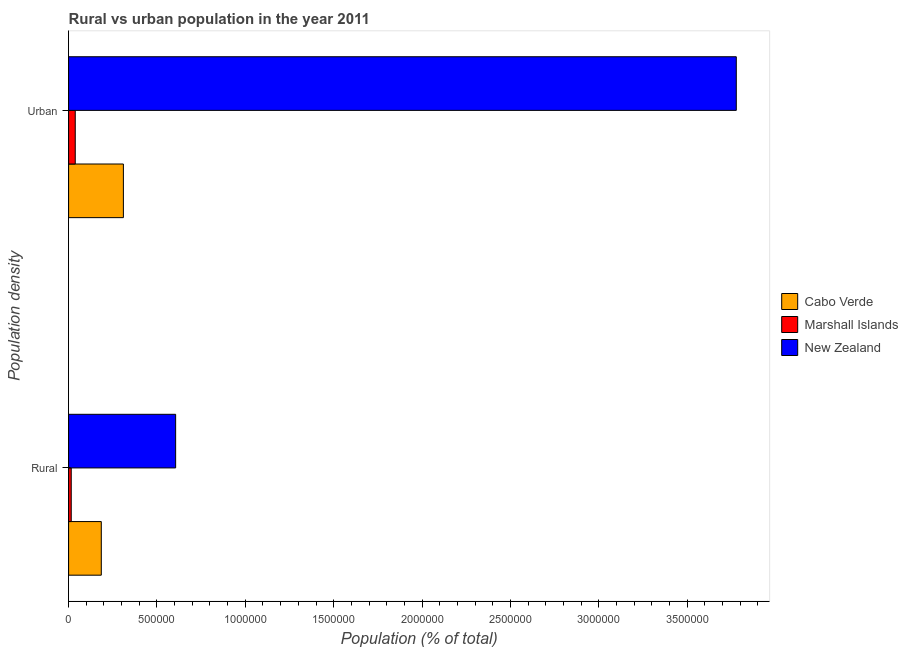How many groups of bars are there?
Offer a terse response. 2. Are the number of bars on each tick of the Y-axis equal?
Give a very brief answer. Yes. How many bars are there on the 2nd tick from the top?
Your answer should be very brief. 3. How many bars are there on the 1st tick from the bottom?
Ensure brevity in your answer.  3. What is the label of the 1st group of bars from the top?
Offer a terse response. Urban. What is the rural population density in Cabo Verde?
Your answer should be very brief. 1.85e+05. Across all countries, what is the maximum urban population density?
Provide a short and direct response. 3.78e+06. Across all countries, what is the minimum rural population density?
Your answer should be compact. 1.49e+04. In which country was the urban population density maximum?
Give a very brief answer. New Zealand. In which country was the rural population density minimum?
Provide a succinct answer. Marshall Islands. What is the total rural population density in the graph?
Offer a terse response. 8.06e+05. What is the difference between the urban population density in Cabo Verde and that in New Zealand?
Give a very brief answer. -3.47e+06. What is the difference between the urban population density in Marshall Islands and the rural population density in New Zealand?
Offer a very short reply. -5.68e+05. What is the average rural population density per country?
Offer a terse response. 2.69e+05. What is the difference between the urban population density and rural population density in New Zealand?
Provide a short and direct response. 3.17e+06. What is the ratio of the rural population density in New Zealand to that in Marshall Islands?
Keep it short and to the point. 40.62. In how many countries, is the rural population density greater than the average rural population density taken over all countries?
Make the answer very short. 1. What does the 1st bar from the top in Rural represents?
Keep it short and to the point. New Zealand. What does the 1st bar from the bottom in Urban represents?
Your response must be concise. Cabo Verde. How many countries are there in the graph?
Offer a terse response. 3. Are the values on the major ticks of X-axis written in scientific E-notation?
Your answer should be very brief. No. Does the graph contain any zero values?
Your response must be concise. No. Where does the legend appear in the graph?
Your answer should be compact. Center right. How many legend labels are there?
Ensure brevity in your answer.  3. How are the legend labels stacked?
Your response must be concise. Vertical. What is the title of the graph?
Keep it short and to the point. Rural vs urban population in the year 2011. What is the label or title of the X-axis?
Ensure brevity in your answer.  Population (% of total). What is the label or title of the Y-axis?
Offer a very short reply. Population density. What is the Population (% of total) in Cabo Verde in Rural?
Offer a terse response. 1.85e+05. What is the Population (% of total) in Marshall Islands in Rural?
Offer a terse response. 1.49e+04. What is the Population (% of total) of New Zealand in Rural?
Provide a short and direct response. 6.06e+05. What is the Population (% of total) of Cabo Verde in Urban?
Your response must be concise. 3.10e+05. What is the Population (% of total) of Marshall Islands in Urban?
Provide a succinct answer. 3.76e+04. What is the Population (% of total) in New Zealand in Urban?
Give a very brief answer. 3.78e+06. Across all Population density, what is the maximum Population (% of total) in Cabo Verde?
Offer a very short reply. 3.10e+05. Across all Population density, what is the maximum Population (% of total) in Marshall Islands?
Offer a very short reply. 3.76e+04. Across all Population density, what is the maximum Population (% of total) of New Zealand?
Provide a succinct answer. 3.78e+06. Across all Population density, what is the minimum Population (% of total) in Cabo Verde?
Ensure brevity in your answer.  1.85e+05. Across all Population density, what is the minimum Population (% of total) of Marshall Islands?
Offer a very short reply. 1.49e+04. Across all Population density, what is the minimum Population (% of total) in New Zealand?
Your answer should be very brief. 6.06e+05. What is the total Population (% of total) in Cabo Verde in the graph?
Make the answer very short. 4.95e+05. What is the total Population (% of total) of Marshall Islands in the graph?
Your answer should be very brief. 5.25e+04. What is the total Population (% of total) of New Zealand in the graph?
Give a very brief answer. 4.38e+06. What is the difference between the Population (% of total) of Cabo Verde in Rural and that in Urban?
Provide a short and direct response. -1.25e+05. What is the difference between the Population (% of total) in Marshall Islands in Rural and that in Urban?
Your answer should be very brief. -2.27e+04. What is the difference between the Population (% of total) in New Zealand in Rural and that in Urban?
Provide a succinct answer. -3.17e+06. What is the difference between the Population (% of total) of Cabo Verde in Rural and the Population (% of total) of Marshall Islands in Urban?
Your response must be concise. 1.47e+05. What is the difference between the Population (% of total) of Cabo Verde in Rural and the Population (% of total) of New Zealand in Urban?
Give a very brief answer. -3.59e+06. What is the difference between the Population (% of total) in Marshall Islands in Rural and the Population (% of total) in New Zealand in Urban?
Ensure brevity in your answer.  -3.76e+06. What is the average Population (% of total) in Cabo Verde per Population density?
Your answer should be compact. 2.48e+05. What is the average Population (% of total) of Marshall Islands per Population density?
Provide a short and direct response. 2.63e+04. What is the average Population (% of total) in New Zealand per Population density?
Give a very brief answer. 2.19e+06. What is the difference between the Population (% of total) of Cabo Verde and Population (% of total) of Marshall Islands in Rural?
Your answer should be compact. 1.70e+05. What is the difference between the Population (% of total) of Cabo Verde and Population (% of total) of New Zealand in Rural?
Provide a succinct answer. -4.21e+05. What is the difference between the Population (% of total) in Marshall Islands and Population (% of total) in New Zealand in Rural?
Your answer should be compact. -5.91e+05. What is the difference between the Population (% of total) of Cabo Verde and Population (% of total) of Marshall Islands in Urban?
Offer a very short reply. 2.72e+05. What is the difference between the Population (% of total) of Cabo Verde and Population (% of total) of New Zealand in Urban?
Your response must be concise. -3.47e+06. What is the difference between the Population (% of total) in Marshall Islands and Population (% of total) in New Zealand in Urban?
Your answer should be compact. -3.74e+06. What is the ratio of the Population (% of total) of Cabo Verde in Rural to that in Urban?
Offer a very short reply. 0.6. What is the ratio of the Population (% of total) of Marshall Islands in Rural to that in Urban?
Keep it short and to the point. 0.4. What is the ratio of the Population (% of total) in New Zealand in Rural to that in Urban?
Offer a terse response. 0.16. What is the difference between the highest and the second highest Population (% of total) in Cabo Verde?
Provide a short and direct response. 1.25e+05. What is the difference between the highest and the second highest Population (% of total) of Marshall Islands?
Keep it short and to the point. 2.27e+04. What is the difference between the highest and the second highest Population (% of total) in New Zealand?
Offer a very short reply. 3.17e+06. What is the difference between the highest and the lowest Population (% of total) in Cabo Verde?
Offer a terse response. 1.25e+05. What is the difference between the highest and the lowest Population (% of total) in Marshall Islands?
Ensure brevity in your answer.  2.27e+04. What is the difference between the highest and the lowest Population (% of total) in New Zealand?
Provide a short and direct response. 3.17e+06. 